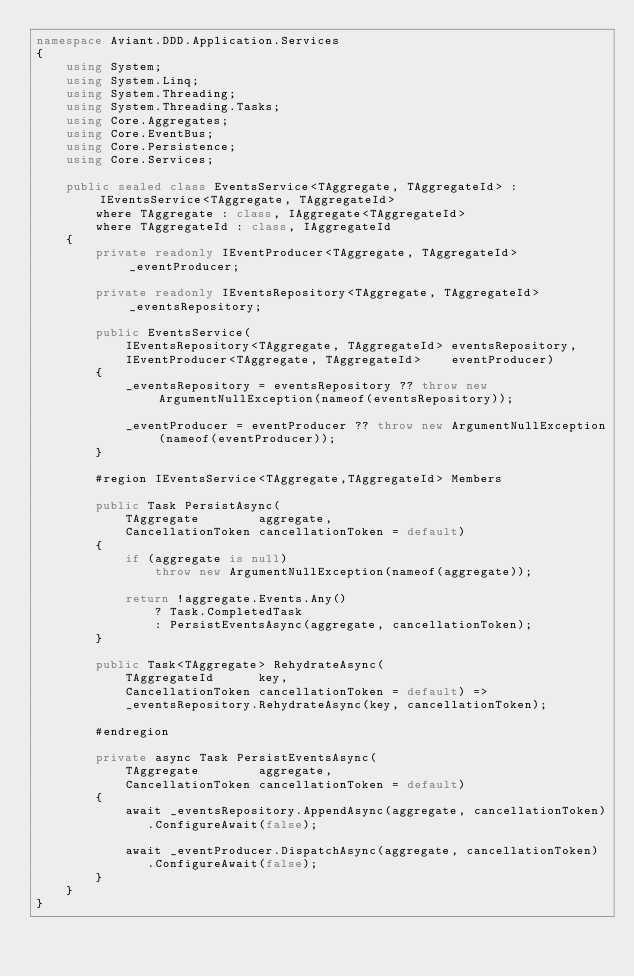Convert code to text. <code><loc_0><loc_0><loc_500><loc_500><_C#_>namespace Aviant.DDD.Application.Services
{
    using System;
    using System.Linq;
    using System.Threading;
    using System.Threading.Tasks;
    using Core.Aggregates;
    using Core.EventBus;
    using Core.Persistence;
    using Core.Services;

    public sealed class EventsService<TAggregate, TAggregateId> : IEventsService<TAggregate, TAggregateId>
        where TAggregate : class, IAggregate<TAggregateId>
        where TAggregateId : class, IAggregateId
    {
        private readonly IEventProducer<TAggregate, TAggregateId> _eventProducer;

        private readonly IEventsRepository<TAggregate, TAggregateId> _eventsRepository;

        public EventsService(
            IEventsRepository<TAggregate, TAggregateId> eventsRepository,
            IEventProducer<TAggregate, TAggregateId>    eventProducer)
        {
            _eventsRepository = eventsRepository ?? throw new ArgumentNullException(nameof(eventsRepository));

            _eventProducer = eventProducer ?? throw new ArgumentNullException(nameof(eventProducer));
        }

        #region IEventsService<TAggregate,TAggregateId> Members

        public Task PersistAsync(
            TAggregate        aggregate,
            CancellationToken cancellationToken = default)
        {
            if (aggregate is null)
                throw new ArgumentNullException(nameof(aggregate));

            return !aggregate.Events.Any()
                ? Task.CompletedTask
                : PersistEventsAsync(aggregate, cancellationToken);
        }

        public Task<TAggregate> RehydrateAsync(
            TAggregateId      key,
            CancellationToken cancellationToken = default) =>
            _eventsRepository.RehydrateAsync(key, cancellationToken);

        #endregion

        private async Task PersistEventsAsync(
            TAggregate        aggregate,
            CancellationToken cancellationToken = default)
        {
            await _eventsRepository.AppendAsync(aggregate, cancellationToken)
               .ConfigureAwait(false);

            await _eventProducer.DispatchAsync(aggregate, cancellationToken)
               .ConfigureAwait(false);
        }
    }
}
</code> 